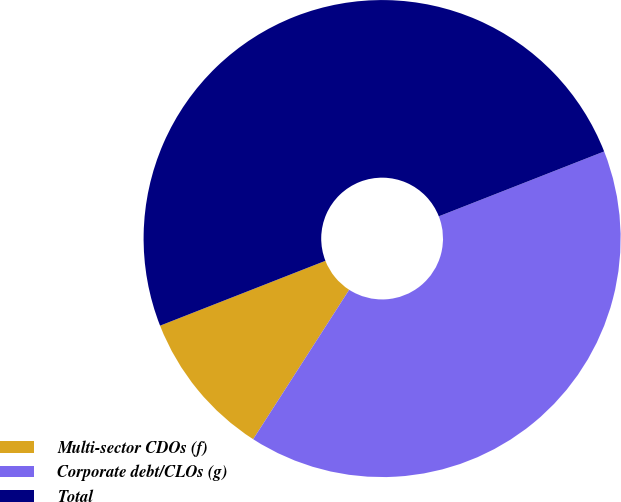Convert chart. <chart><loc_0><loc_0><loc_500><loc_500><pie_chart><fcel>Multi-sector CDOs (f)<fcel>Corporate debt/CLOs (g)<fcel>Total<nl><fcel>9.96%<fcel>40.04%<fcel>50.0%<nl></chart> 